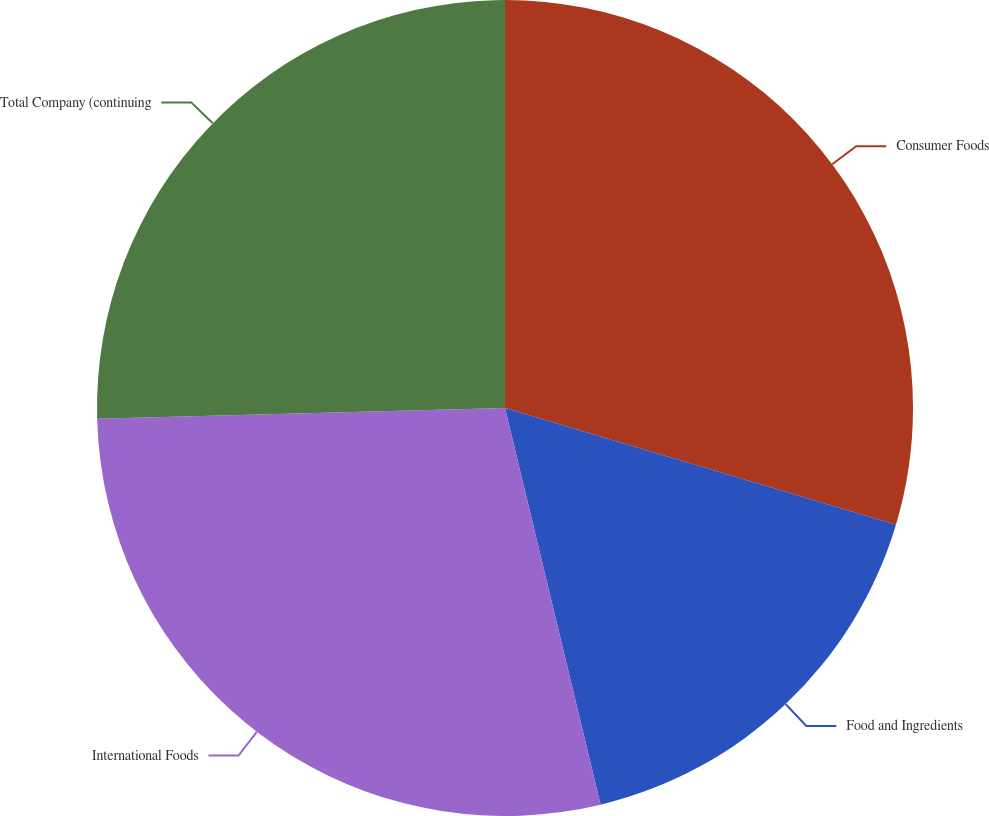<chart> <loc_0><loc_0><loc_500><loc_500><pie_chart><fcel>Consumer Foods<fcel>Food and Ingredients<fcel>International Foods<fcel>Total Company (continuing<nl><fcel>29.62%<fcel>16.62%<fcel>28.35%<fcel>25.42%<nl></chart> 